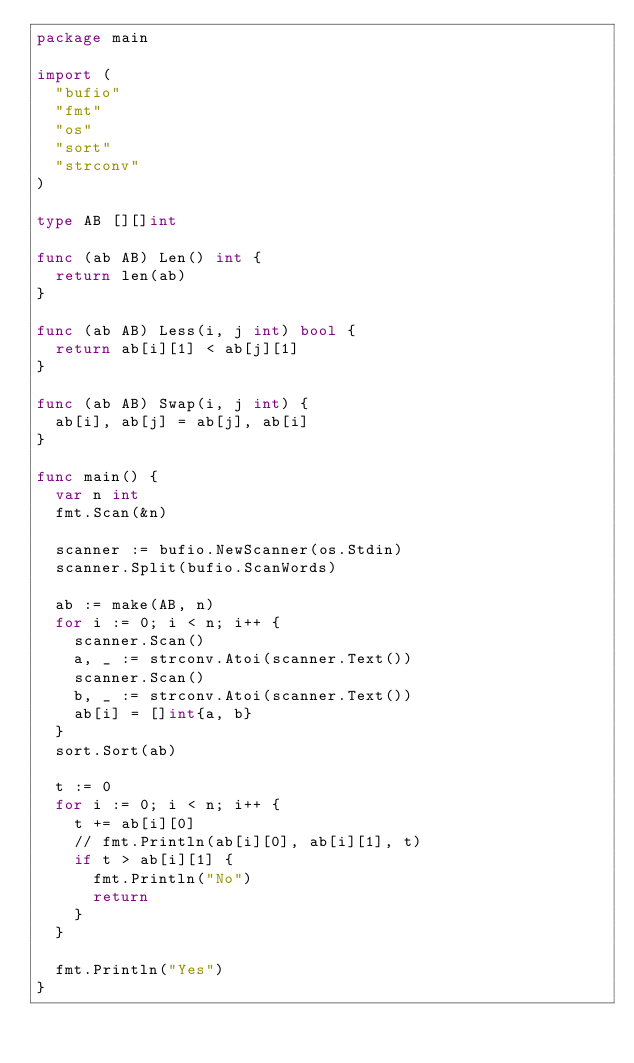<code> <loc_0><loc_0><loc_500><loc_500><_Go_>package main

import (
	"bufio"
	"fmt"
	"os"
	"sort"
	"strconv"
)

type AB [][]int

func (ab AB) Len() int {
	return len(ab)
}

func (ab AB) Less(i, j int) bool {
	return ab[i][1] < ab[j][1]
}

func (ab AB) Swap(i, j int) {
	ab[i], ab[j] = ab[j], ab[i]
}

func main() {
	var n int
	fmt.Scan(&n)

	scanner := bufio.NewScanner(os.Stdin)
	scanner.Split(bufio.ScanWords)

	ab := make(AB, n)
	for i := 0; i < n; i++ {
		scanner.Scan()
		a, _ := strconv.Atoi(scanner.Text())
		scanner.Scan()
		b, _ := strconv.Atoi(scanner.Text())
		ab[i] = []int{a, b}
	}
	sort.Sort(ab)

	t := 0
	for i := 0; i < n; i++ {
		t += ab[i][0]
		// fmt.Println(ab[i][0], ab[i][1], t)
		if t > ab[i][1] {
			fmt.Println("No")
			return
		}
	}

	fmt.Println("Yes")
}
</code> 